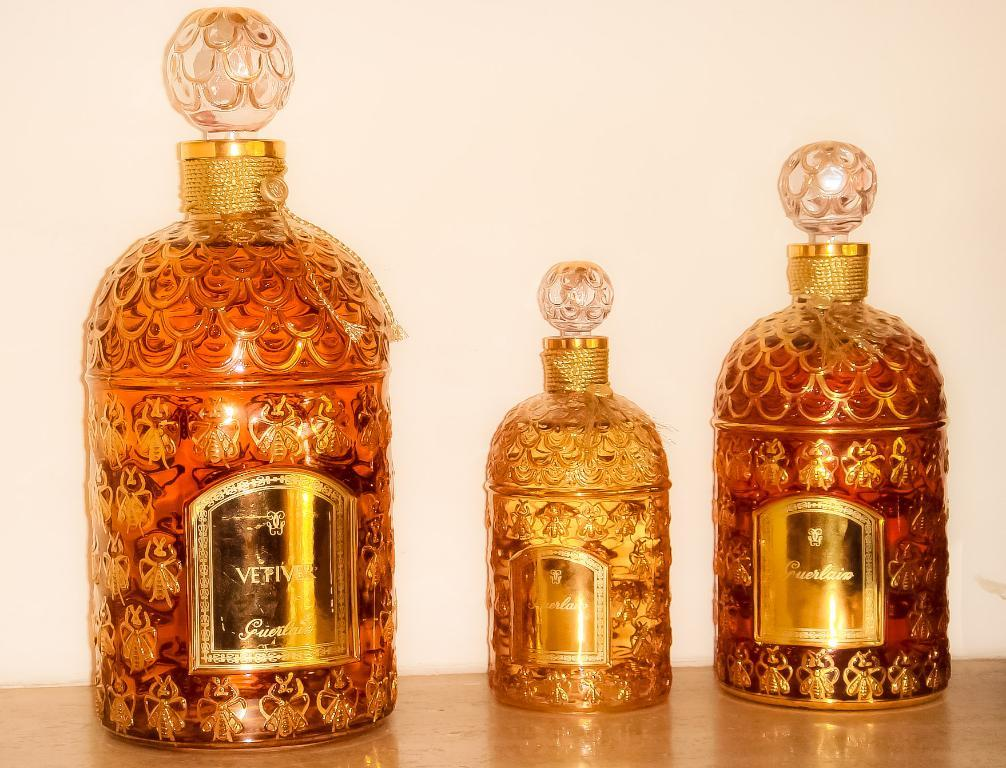How many alcohol bottles are visible in the image? There are three alcohol bottles in the image. Where are the alcohol bottles located in the image? The alcohol bottles are placed on a surface. What type of door can be seen in the image? There is no door present in the image; it only features three alcohol bottles placed on a surface. How many straws are visible in the image? There are no straws visible in the image; it only features three alcohol bottles placed on a surface. 